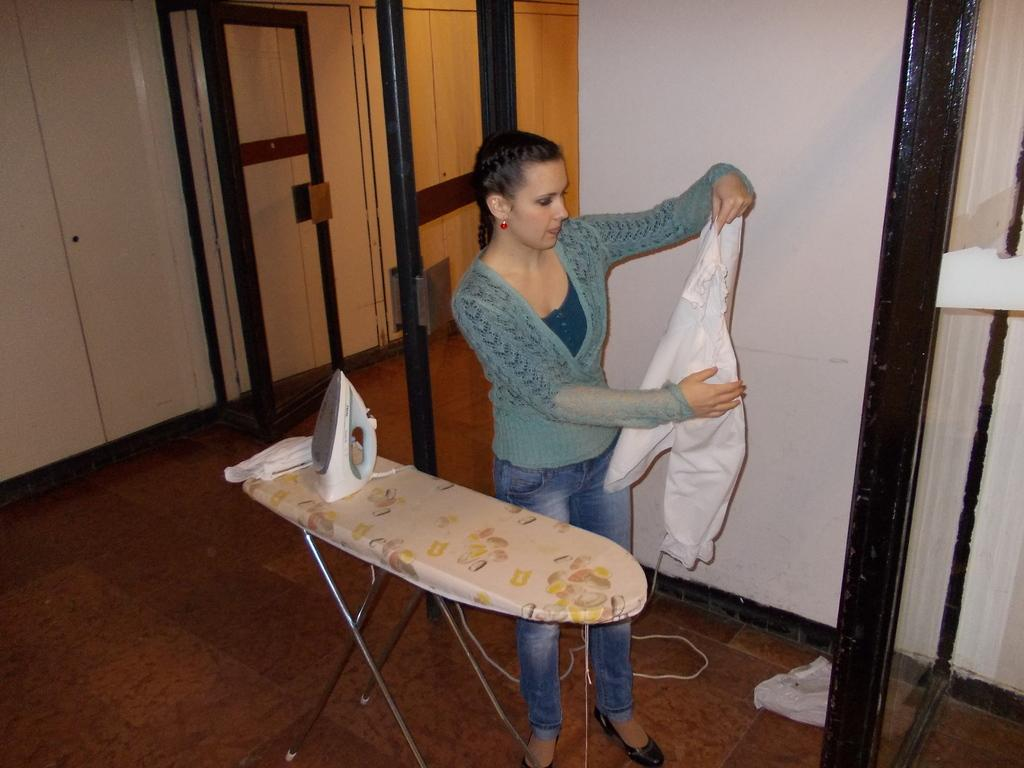What can be seen in the background of the image? In the background of the image, there is a wall, a door, and a cupboard. What is the woman in the image doing? The woman is holding a shirt in her hands. What object is present on the table in the image? There is an iron box on the table in the image. What is the surface visible in the image? The image is showing a floor. Reasoning: Let' Let's think step by step in order to produce the conversation. We start by identifying the main subjects and objects in the image based on the provided facts. We then formulate questions that focus on the location and characteristics of these subjects and objects, ensuring that each question can be answered definitively with the information given. We avoid yes/no questions and ensure that the language is simple and clear. Absurd Question/Answer: Can you see a robin perched on the cupboard in the image? No, there is no robin present in the image. What type of tail is attached to the shirt the woman is holding? The shirt does not have a tail, and the image does not show any tails. 